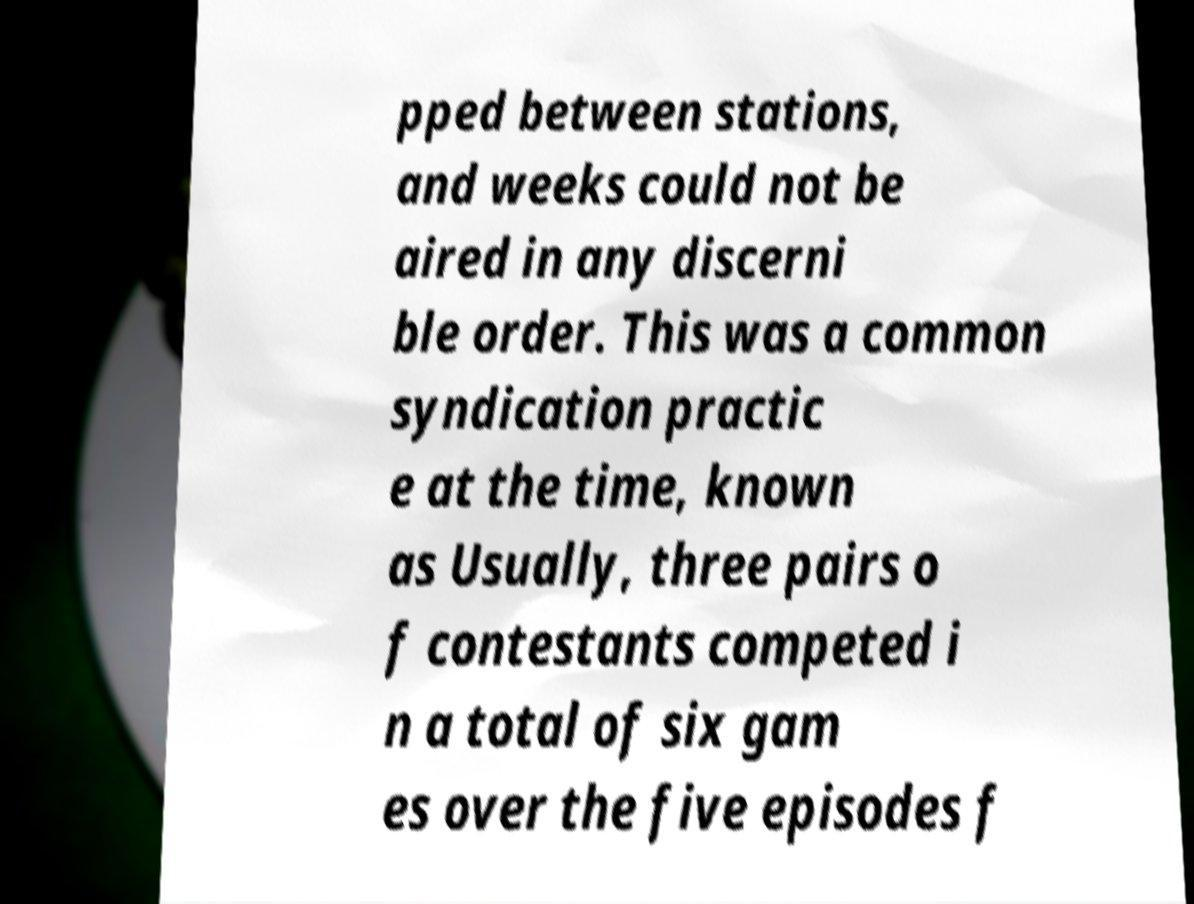For documentation purposes, I need the text within this image transcribed. Could you provide that? pped between stations, and weeks could not be aired in any discerni ble order. This was a common syndication practic e at the time, known as Usually, three pairs o f contestants competed i n a total of six gam es over the five episodes f 